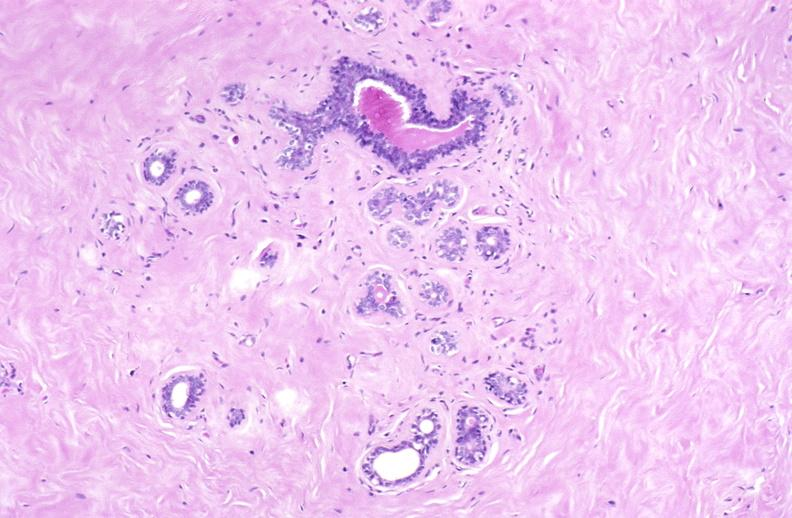what does this image show?
Answer the question using a single word or phrase. Breast 